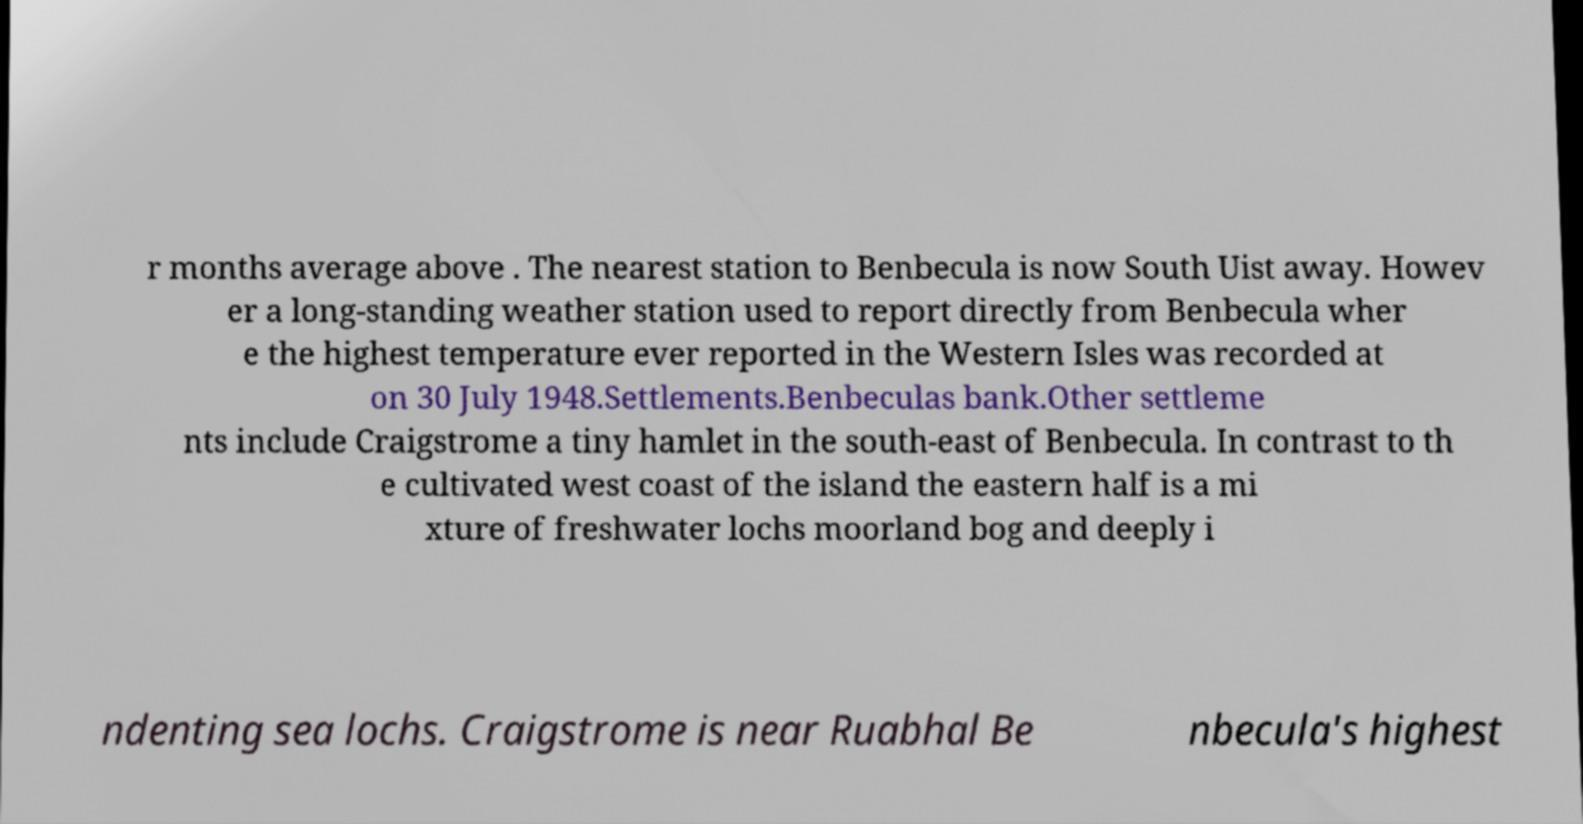There's text embedded in this image that I need extracted. Can you transcribe it verbatim? r months average above . The nearest station to Benbecula is now South Uist away. Howev er a long-standing weather station used to report directly from Benbecula wher e the highest temperature ever reported in the Western Isles was recorded at on 30 July 1948.Settlements.Benbeculas bank.Other settleme nts include Craigstrome a tiny hamlet in the south-east of Benbecula. In contrast to th e cultivated west coast of the island the eastern half is a mi xture of freshwater lochs moorland bog and deeply i ndenting sea lochs. Craigstrome is near Ruabhal Be nbecula's highest 